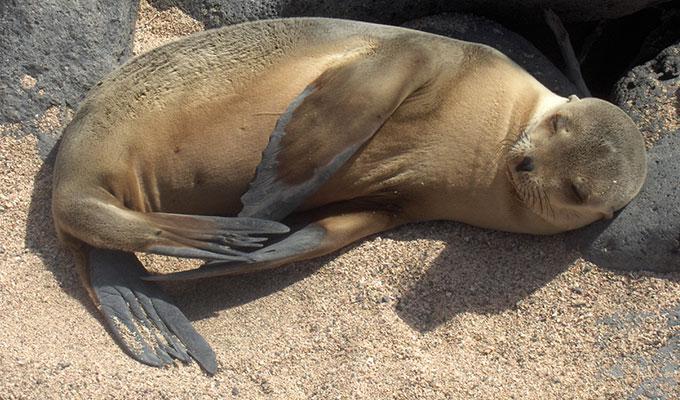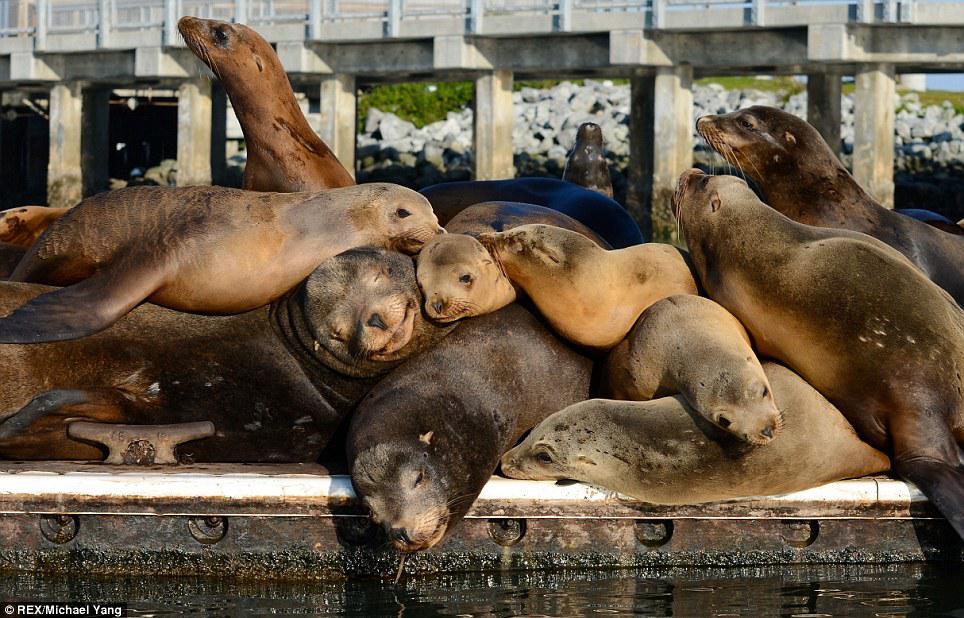The first image is the image on the left, the second image is the image on the right. Evaluate the accuracy of this statement regarding the images: "The left hand image shows less than four seals laying on the ground.". Is it true? Answer yes or no. Yes. The first image is the image on the left, the second image is the image on the right. Evaluate the accuracy of this statement regarding the images: "One image shows no more than three seals in the foreground, and the other shows seals piled on top of each other.". Is it true? Answer yes or no. Yes. 